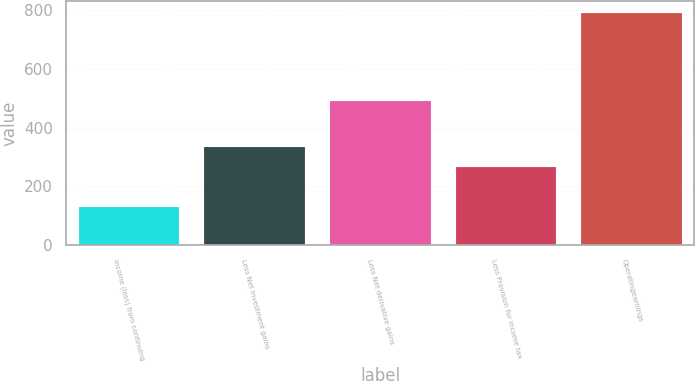Convert chart. <chart><loc_0><loc_0><loc_500><loc_500><bar_chart><fcel>Income (loss) from continuing<fcel>Less Net investment gains<fcel>Less Net derivative gains<fcel>Less Provision for income tax<fcel>Operatingearnings<nl><fcel>131<fcel>334.1<fcel>491<fcel>268<fcel>792<nl></chart> 